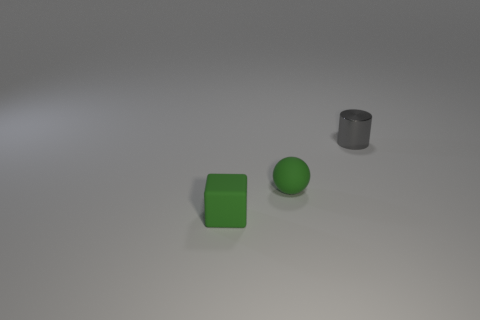Add 1 tiny green spheres. How many objects exist? 4 Subtract all cylinders. How many objects are left? 2 Subtract all small blue blocks. Subtract all gray shiny cylinders. How many objects are left? 2 Add 3 green matte cubes. How many green matte cubes are left? 4 Add 3 big green matte things. How many big green matte things exist? 3 Subtract 1 green blocks. How many objects are left? 2 Subtract all yellow balls. Subtract all brown cylinders. How many balls are left? 1 